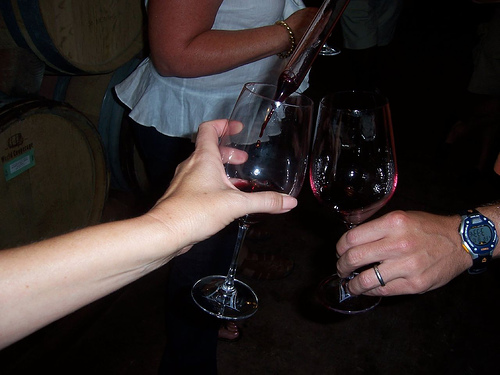<image>What flavoring is being placed in the drinks? It is ambiguous what flavoring is being placed in the drinks. It could be red wine or cherry. What flavoring is being placed in the drinks? I don't know what flavoring is being placed in the drinks. It can be either cherry or red wine. 